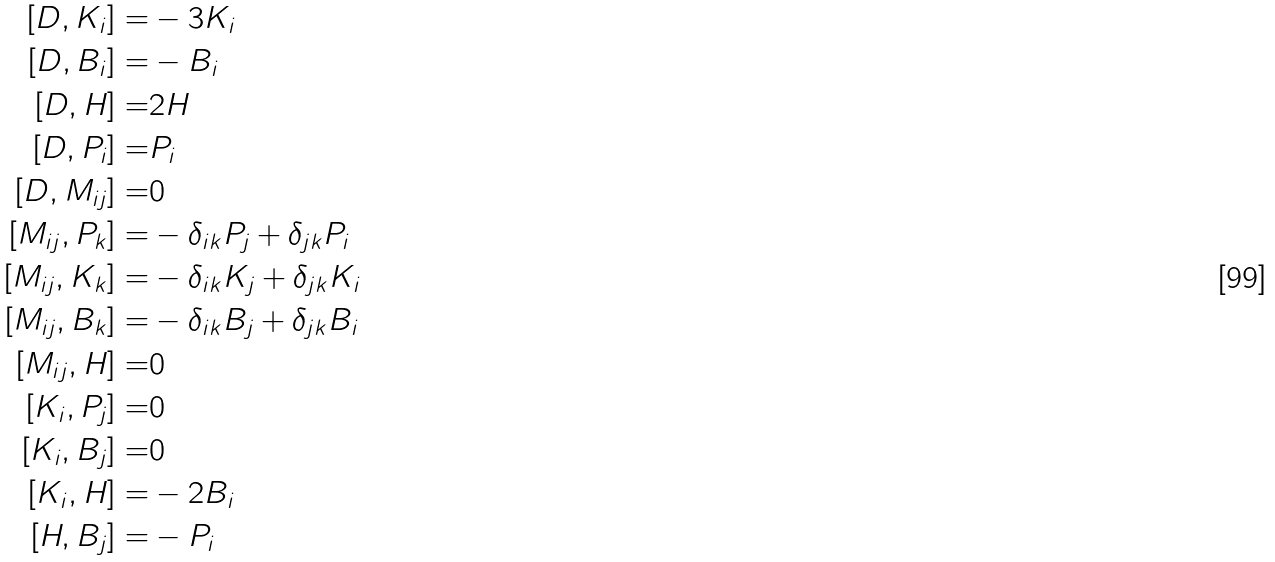Convert formula to latex. <formula><loc_0><loc_0><loc_500><loc_500>[ D , K _ { i } ] = & - 3 K _ { i } \\ [ D , B _ { i } ] = & - B _ { i } \\ [ D , H ] = & 2 H \\ [ D , P _ { i } ] = & P _ { i } \\ [ D , M _ { i j } ] = & 0 \\ [ M _ { i j } , P _ { k } ] = & - \delta _ { i k } P _ { j } + \delta _ { j k } P _ { i } \\ [ M _ { i j } , K _ { k } ] = & - \delta _ { i k } K _ { j } + \delta _ { j k } K _ { i } \\ [ M _ { i j } , B _ { k } ] = & - \delta _ { i k } B _ { j } + \delta _ { j k } B _ { i } \\ [ M _ { i j } , H ] = & 0 \\ [ K _ { i } , P _ { j } ] = & 0 \\ [ K _ { i } , B _ { j } ] = & 0 \\ [ K _ { i } , H ] = & - 2 B _ { i } \\ [ H , B _ { j } ] = & - P _ { i } \\</formula> 